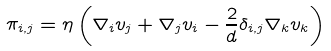<formula> <loc_0><loc_0><loc_500><loc_500>\pi _ { i , j } = \eta \left ( \nabla _ { i } v _ { j } + \nabla _ { j } v _ { i } - \frac { 2 } { d } \delta _ { i , j } \nabla _ { k } v _ { k } \right )</formula> 